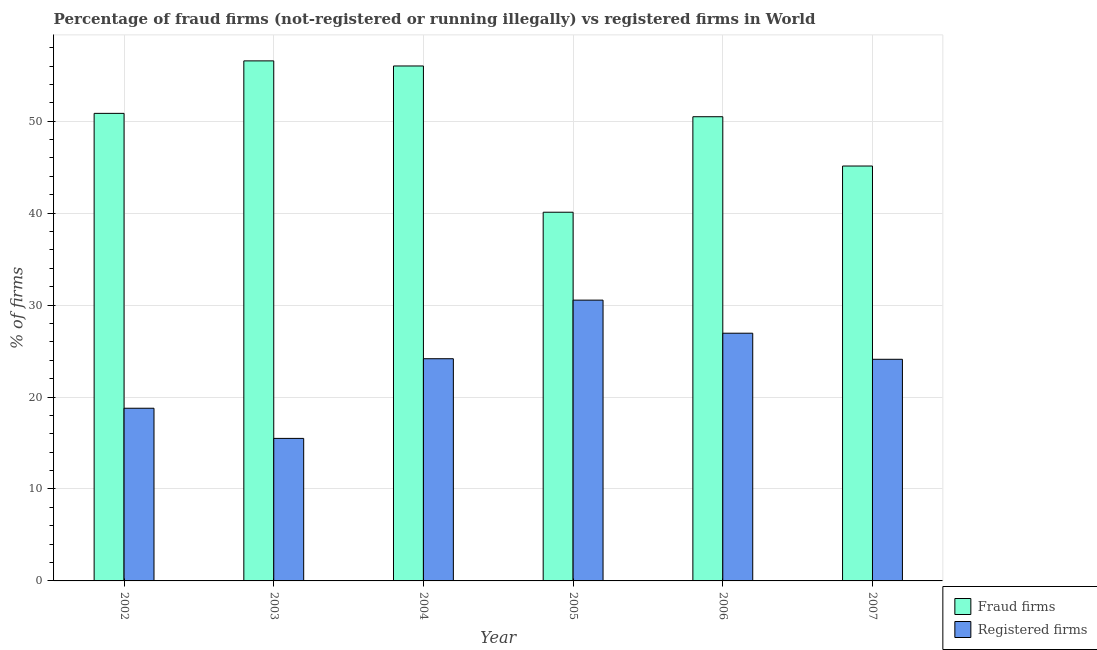How many groups of bars are there?
Provide a short and direct response. 6. Are the number of bars per tick equal to the number of legend labels?
Your response must be concise. Yes. How many bars are there on the 3rd tick from the right?
Make the answer very short. 2. What is the label of the 6th group of bars from the left?
Your answer should be compact. 2007. What is the percentage of registered firms in 2006?
Your answer should be compact. 26.94. Across all years, what is the maximum percentage of fraud firms?
Keep it short and to the point. 56.56. Across all years, what is the minimum percentage of registered firms?
Make the answer very short. 15.5. In which year was the percentage of fraud firms maximum?
Your answer should be very brief. 2003. What is the total percentage of fraud firms in the graph?
Make the answer very short. 299.13. What is the difference between the percentage of registered firms in 2002 and that in 2003?
Keep it short and to the point. 3.28. What is the difference between the percentage of fraud firms in 2006 and the percentage of registered firms in 2007?
Your answer should be compact. 5.36. What is the average percentage of registered firms per year?
Give a very brief answer. 23.34. In how many years, is the percentage of registered firms greater than 30 %?
Offer a very short reply. 1. What is the ratio of the percentage of registered firms in 2002 to that in 2005?
Your answer should be very brief. 0.61. What is the difference between the highest and the second highest percentage of fraud firms?
Provide a short and direct response. 0.55. What is the difference between the highest and the lowest percentage of registered firms?
Provide a short and direct response. 15.04. In how many years, is the percentage of fraud firms greater than the average percentage of fraud firms taken over all years?
Provide a succinct answer. 4. What does the 1st bar from the left in 2004 represents?
Offer a terse response. Fraud firms. What does the 2nd bar from the right in 2007 represents?
Your answer should be compact. Fraud firms. How many years are there in the graph?
Offer a very short reply. 6. What is the difference between two consecutive major ticks on the Y-axis?
Your answer should be compact. 10. Does the graph contain any zero values?
Give a very brief answer. No. Does the graph contain grids?
Make the answer very short. Yes. Where does the legend appear in the graph?
Give a very brief answer. Bottom right. How are the legend labels stacked?
Your answer should be very brief. Vertical. What is the title of the graph?
Your answer should be compact. Percentage of fraud firms (not-registered or running illegally) vs registered firms in World. Does "All education staff compensation" appear as one of the legend labels in the graph?
Give a very brief answer. No. What is the label or title of the Y-axis?
Give a very brief answer. % of firms. What is the % of firms in Fraud firms in 2002?
Ensure brevity in your answer.  50.85. What is the % of firms in Registered firms in 2002?
Offer a very short reply. 18.78. What is the % of firms of Fraud firms in 2003?
Ensure brevity in your answer.  56.56. What is the % of firms in Registered firms in 2003?
Keep it short and to the point. 15.5. What is the % of firms in Fraud firms in 2004?
Provide a succinct answer. 56.01. What is the % of firms in Registered firms in 2004?
Your answer should be compact. 24.17. What is the % of firms of Fraud firms in 2005?
Ensure brevity in your answer.  40.1. What is the % of firms of Registered firms in 2005?
Your answer should be compact. 30.54. What is the % of firms of Fraud firms in 2006?
Ensure brevity in your answer.  50.49. What is the % of firms in Registered firms in 2006?
Your answer should be very brief. 26.94. What is the % of firms in Fraud firms in 2007?
Your answer should be compact. 45.12. What is the % of firms of Registered firms in 2007?
Make the answer very short. 24.11. Across all years, what is the maximum % of firms of Fraud firms?
Offer a terse response. 56.56. Across all years, what is the maximum % of firms of Registered firms?
Your answer should be very brief. 30.54. Across all years, what is the minimum % of firms in Fraud firms?
Offer a terse response. 40.1. What is the total % of firms in Fraud firms in the graph?
Make the answer very short. 299.13. What is the total % of firms in Registered firms in the graph?
Make the answer very short. 140.03. What is the difference between the % of firms in Fraud firms in 2002 and that in 2003?
Provide a succinct answer. -5.71. What is the difference between the % of firms in Registered firms in 2002 and that in 2003?
Your response must be concise. 3.28. What is the difference between the % of firms in Fraud firms in 2002 and that in 2004?
Keep it short and to the point. -5.15. What is the difference between the % of firms in Registered firms in 2002 and that in 2004?
Your answer should be compact. -5.39. What is the difference between the % of firms in Fraud firms in 2002 and that in 2005?
Provide a short and direct response. 10.75. What is the difference between the % of firms in Registered firms in 2002 and that in 2005?
Ensure brevity in your answer.  -11.76. What is the difference between the % of firms of Fraud firms in 2002 and that in 2006?
Your answer should be compact. 0.36. What is the difference between the % of firms in Registered firms in 2002 and that in 2006?
Offer a very short reply. -8.16. What is the difference between the % of firms in Fraud firms in 2002 and that in 2007?
Offer a very short reply. 5.73. What is the difference between the % of firms in Registered firms in 2002 and that in 2007?
Your answer should be compact. -5.32. What is the difference between the % of firms in Fraud firms in 2003 and that in 2004?
Your response must be concise. 0.56. What is the difference between the % of firms in Registered firms in 2003 and that in 2004?
Offer a very short reply. -8.67. What is the difference between the % of firms of Fraud firms in 2003 and that in 2005?
Offer a terse response. 16.46. What is the difference between the % of firms of Registered firms in 2003 and that in 2005?
Provide a short and direct response. -15.04. What is the difference between the % of firms in Fraud firms in 2003 and that in 2006?
Give a very brief answer. 6.07. What is the difference between the % of firms of Registered firms in 2003 and that in 2006?
Offer a very short reply. -11.44. What is the difference between the % of firms in Fraud firms in 2003 and that in 2007?
Your answer should be compact. 11.44. What is the difference between the % of firms of Registered firms in 2003 and that in 2007?
Provide a short and direct response. -8.61. What is the difference between the % of firms in Fraud firms in 2004 and that in 2005?
Offer a very short reply. 15.91. What is the difference between the % of firms in Registered firms in 2004 and that in 2005?
Your answer should be compact. -6.37. What is the difference between the % of firms in Fraud firms in 2004 and that in 2006?
Offer a very short reply. 5.52. What is the difference between the % of firms in Registered firms in 2004 and that in 2006?
Your response must be concise. -2.77. What is the difference between the % of firms of Fraud firms in 2004 and that in 2007?
Provide a succinct answer. 10.88. What is the difference between the % of firms in Registered firms in 2004 and that in 2007?
Ensure brevity in your answer.  0.06. What is the difference between the % of firms in Fraud firms in 2005 and that in 2006?
Keep it short and to the point. -10.39. What is the difference between the % of firms of Registered firms in 2005 and that in 2006?
Make the answer very short. 3.6. What is the difference between the % of firms of Fraud firms in 2005 and that in 2007?
Provide a short and direct response. -5.02. What is the difference between the % of firms of Registered firms in 2005 and that in 2007?
Make the answer very short. 6.43. What is the difference between the % of firms of Fraud firms in 2006 and that in 2007?
Your answer should be compact. 5.36. What is the difference between the % of firms in Registered firms in 2006 and that in 2007?
Your response must be concise. 2.83. What is the difference between the % of firms in Fraud firms in 2002 and the % of firms in Registered firms in 2003?
Your answer should be compact. 35.35. What is the difference between the % of firms of Fraud firms in 2002 and the % of firms of Registered firms in 2004?
Offer a terse response. 26.68. What is the difference between the % of firms of Fraud firms in 2002 and the % of firms of Registered firms in 2005?
Make the answer very short. 20.31. What is the difference between the % of firms in Fraud firms in 2002 and the % of firms in Registered firms in 2006?
Keep it short and to the point. 23.91. What is the difference between the % of firms in Fraud firms in 2002 and the % of firms in Registered firms in 2007?
Your answer should be compact. 26.75. What is the difference between the % of firms in Fraud firms in 2003 and the % of firms in Registered firms in 2004?
Give a very brief answer. 32.39. What is the difference between the % of firms in Fraud firms in 2003 and the % of firms in Registered firms in 2005?
Your response must be concise. 26.02. What is the difference between the % of firms in Fraud firms in 2003 and the % of firms in Registered firms in 2006?
Ensure brevity in your answer.  29.62. What is the difference between the % of firms in Fraud firms in 2003 and the % of firms in Registered firms in 2007?
Offer a terse response. 32.45. What is the difference between the % of firms of Fraud firms in 2004 and the % of firms of Registered firms in 2005?
Your answer should be compact. 25.47. What is the difference between the % of firms of Fraud firms in 2004 and the % of firms of Registered firms in 2006?
Offer a terse response. 29.06. What is the difference between the % of firms in Fraud firms in 2004 and the % of firms in Registered firms in 2007?
Offer a very short reply. 31.9. What is the difference between the % of firms of Fraud firms in 2005 and the % of firms of Registered firms in 2006?
Provide a succinct answer. 13.16. What is the difference between the % of firms in Fraud firms in 2005 and the % of firms in Registered firms in 2007?
Your answer should be very brief. 15.99. What is the difference between the % of firms in Fraud firms in 2006 and the % of firms in Registered firms in 2007?
Provide a succinct answer. 26.38. What is the average % of firms in Fraud firms per year?
Give a very brief answer. 49.85. What is the average % of firms in Registered firms per year?
Keep it short and to the point. 23.34. In the year 2002, what is the difference between the % of firms in Fraud firms and % of firms in Registered firms?
Ensure brevity in your answer.  32.07. In the year 2003, what is the difference between the % of firms in Fraud firms and % of firms in Registered firms?
Make the answer very short. 41.06. In the year 2004, what is the difference between the % of firms of Fraud firms and % of firms of Registered firms?
Offer a terse response. 31.84. In the year 2005, what is the difference between the % of firms of Fraud firms and % of firms of Registered firms?
Keep it short and to the point. 9.56. In the year 2006, what is the difference between the % of firms of Fraud firms and % of firms of Registered firms?
Provide a succinct answer. 23.55. In the year 2007, what is the difference between the % of firms of Fraud firms and % of firms of Registered firms?
Offer a terse response. 21.02. What is the ratio of the % of firms of Fraud firms in 2002 to that in 2003?
Your answer should be very brief. 0.9. What is the ratio of the % of firms of Registered firms in 2002 to that in 2003?
Offer a terse response. 1.21. What is the ratio of the % of firms in Fraud firms in 2002 to that in 2004?
Offer a terse response. 0.91. What is the ratio of the % of firms of Registered firms in 2002 to that in 2004?
Give a very brief answer. 0.78. What is the ratio of the % of firms in Fraud firms in 2002 to that in 2005?
Provide a succinct answer. 1.27. What is the ratio of the % of firms of Registered firms in 2002 to that in 2005?
Your answer should be very brief. 0.61. What is the ratio of the % of firms of Registered firms in 2002 to that in 2006?
Offer a very short reply. 0.7. What is the ratio of the % of firms in Fraud firms in 2002 to that in 2007?
Your response must be concise. 1.13. What is the ratio of the % of firms in Registered firms in 2002 to that in 2007?
Keep it short and to the point. 0.78. What is the ratio of the % of firms in Fraud firms in 2003 to that in 2004?
Keep it short and to the point. 1.01. What is the ratio of the % of firms of Registered firms in 2003 to that in 2004?
Your response must be concise. 0.64. What is the ratio of the % of firms in Fraud firms in 2003 to that in 2005?
Offer a terse response. 1.41. What is the ratio of the % of firms of Registered firms in 2003 to that in 2005?
Offer a terse response. 0.51. What is the ratio of the % of firms of Fraud firms in 2003 to that in 2006?
Your answer should be very brief. 1.12. What is the ratio of the % of firms of Registered firms in 2003 to that in 2006?
Your answer should be very brief. 0.58. What is the ratio of the % of firms in Fraud firms in 2003 to that in 2007?
Your answer should be compact. 1.25. What is the ratio of the % of firms of Registered firms in 2003 to that in 2007?
Offer a terse response. 0.64. What is the ratio of the % of firms of Fraud firms in 2004 to that in 2005?
Offer a very short reply. 1.4. What is the ratio of the % of firms of Registered firms in 2004 to that in 2005?
Your answer should be compact. 0.79. What is the ratio of the % of firms of Fraud firms in 2004 to that in 2006?
Offer a terse response. 1.11. What is the ratio of the % of firms of Registered firms in 2004 to that in 2006?
Your answer should be very brief. 0.9. What is the ratio of the % of firms in Fraud firms in 2004 to that in 2007?
Your response must be concise. 1.24. What is the ratio of the % of firms in Registered firms in 2004 to that in 2007?
Your response must be concise. 1. What is the ratio of the % of firms in Fraud firms in 2005 to that in 2006?
Ensure brevity in your answer.  0.79. What is the ratio of the % of firms of Registered firms in 2005 to that in 2006?
Provide a succinct answer. 1.13. What is the ratio of the % of firms in Fraud firms in 2005 to that in 2007?
Your answer should be compact. 0.89. What is the ratio of the % of firms of Registered firms in 2005 to that in 2007?
Offer a terse response. 1.27. What is the ratio of the % of firms in Fraud firms in 2006 to that in 2007?
Give a very brief answer. 1.12. What is the ratio of the % of firms of Registered firms in 2006 to that in 2007?
Your response must be concise. 1.12. What is the difference between the highest and the second highest % of firms in Fraud firms?
Ensure brevity in your answer.  0.56. What is the difference between the highest and the second highest % of firms in Registered firms?
Give a very brief answer. 3.6. What is the difference between the highest and the lowest % of firms of Fraud firms?
Make the answer very short. 16.46. What is the difference between the highest and the lowest % of firms in Registered firms?
Provide a short and direct response. 15.04. 